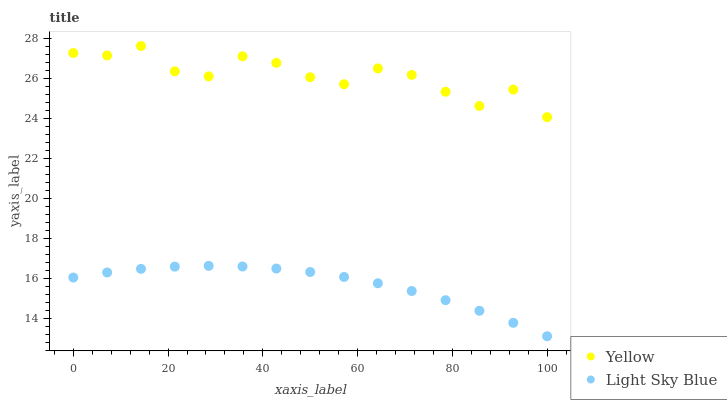Does Light Sky Blue have the minimum area under the curve?
Answer yes or no. Yes. Does Yellow have the maximum area under the curve?
Answer yes or no. Yes. Does Yellow have the minimum area under the curve?
Answer yes or no. No. Is Light Sky Blue the smoothest?
Answer yes or no. Yes. Is Yellow the roughest?
Answer yes or no. Yes. Is Yellow the smoothest?
Answer yes or no. No. Does Light Sky Blue have the lowest value?
Answer yes or no. Yes. Does Yellow have the lowest value?
Answer yes or no. No. Does Yellow have the highest value?
Answer yes or no. Yes. Is Light Sky Blue less than Yellow?
Answer yes or no. Yes. Is Yellow greater than Light Sky Blue?
Answer yes or no. Yes. Does Light Sky Blue intersect Yellow?
Answer yes or no. No. 